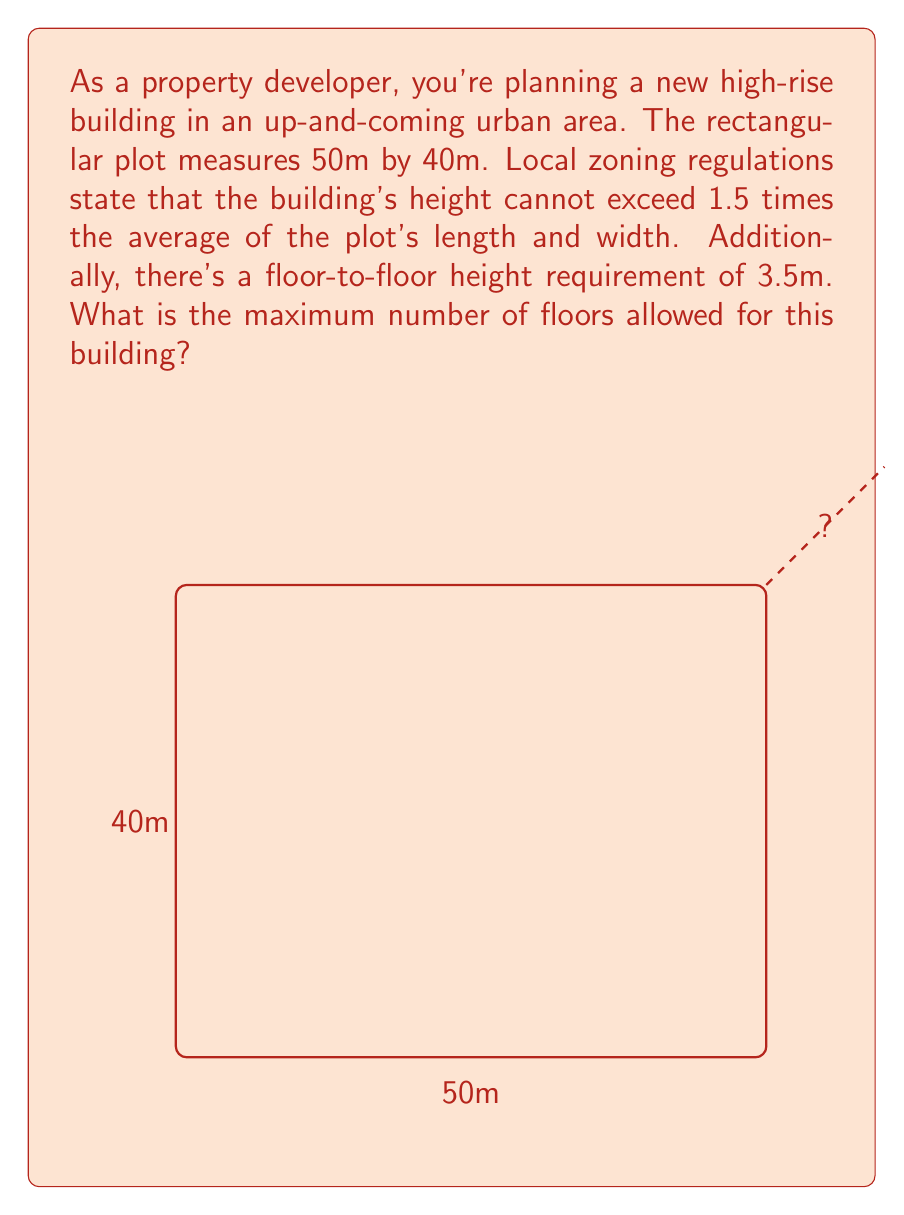Help me with this question. Let's approach this step-by-step:

1) First, we need to calculate the average of the plot's length and width:
   $$ \text{Average} = \frac{\text{Length} + \text{Width}}{2} = \frac{50\text{m} + 40\text{m}}{2} = 45\text{m} $$

2) The maximum building height is 1.5 times this average:
   $$ \text{Max Height} = 1.5 \times 45\text{m} = 67.5\text{m} $$

3) Now, we need to determine how many floors can fit within this height. We know each floor requires 3.5m:
   $$ \text{Number of Floors} = \frac{\text{Max Height}}{\text{Floor Height}} = \frac{67.5\text{m}}{3.5\text{m}} = 19.29 $$

4) Since we can't have a fractional number of floors, we need to round down to the nearest whole number.

Therefore, the maximum number of floors allowed is 19.
Answer: 19 floors 